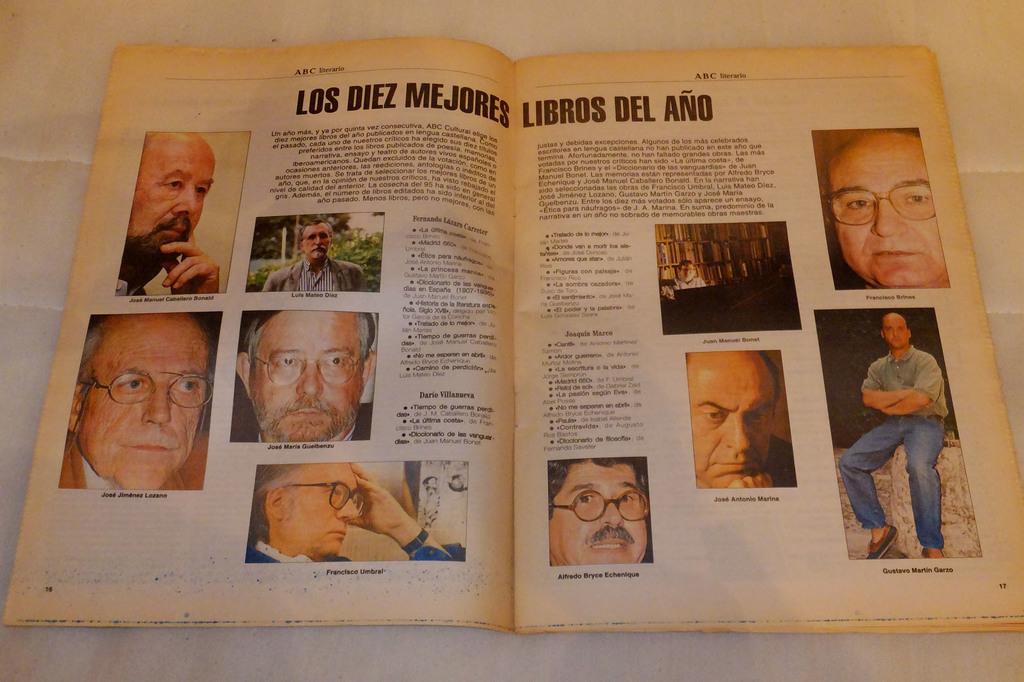Could you give a brief overview of what you see in this image? In this image we can see a book with some pictures and text is placed on the surface. 